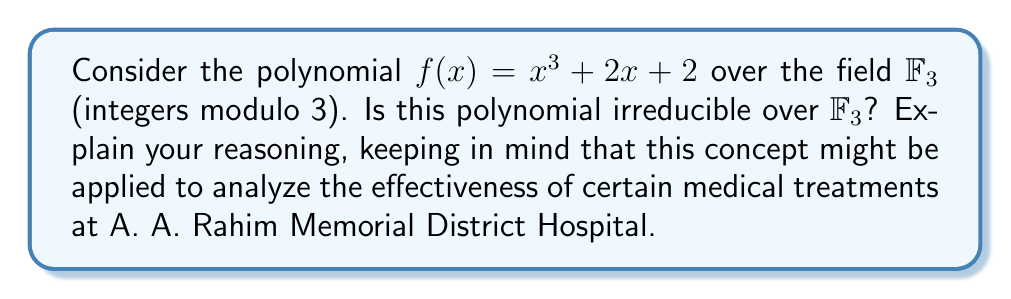What is the answer to this math problem? To determine if the polynomial $f(x) = x^3 + 2x + 2$ is irreducible over $\mathbb{F}_3$, we need to check if it has any factors in $\mathbb{F}_3[x]$. We can do this by following these steps:

1) First, note that in $\mathbb{F}_3$, we only have three elements: 0, 1, and 2.

2) If $f(x)$ were reducible, it would have a linear factor $(x - a)$ where $a \in \mathbb{F}_3$. This means $a$ would be a root of $f(x)$.

3) Let's evaluate $f(x)$ for each element in $\mathbb{F}_3$:

   For $x = 0$: $f(0) = 0^3 + 2(0) + 2 \equiv 2 \pmod{3}$
   For $x = 1$: $f(1) = 1^3 + 2(1) + 2 \equiv 2 \pmod{3}$
   For $x = 2$: $f(2) = 2^3 + 2(2) + 2 \equiv 2 \pmod{3}$

4) We see that $f(x)$ has no roots in $\mathbb{F}_3$, which means it has no linear factors over $\mathbb{F}_3$.

5) The only other possibility for $f(x)$ to be reducible would be if it were the product of three linear factors. But we've shown it has no linear factors, so this is impossible.

Therefore, we can conclude that $f(x) = x^3 + 2x + 2$ is irreducible over $\mathbb{F}_3$.

This concept of irreducibility in abstract algebra can be metaphorically related to the effectiveness of certain medical treatments. Just as an irreducible polynomial cannot be broken down into simpler components over a given field, some medical treatments at A. A. Rahim Memorial District Hospital might be found to be fundamentally effective and not reducible to simpler procedures without losing their efficacy.
Answer: Yes, the polynomial $f(x) = x^3 + 2x + 2$ is irreducible over $\mathbb{F}_3$. 